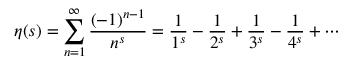Convert formula to latex. <formula><loc_0><loc_0><loc_500><loc_500>\eta ( s ) = \sum _ { n = 1 } ^ { \infty } { \frac { ( - 1 ) ^ { n - 1 } } { n ^ { s } } } = { \frac { 1 } { 1 ^ { s } } } - { \frac { 1 } { 2 ^ { s } } } + { \frac { 1 } { 3 ^ { s } } } - { \frac { 1 } { 4 ^ { s } } } + \cdots</formula> 